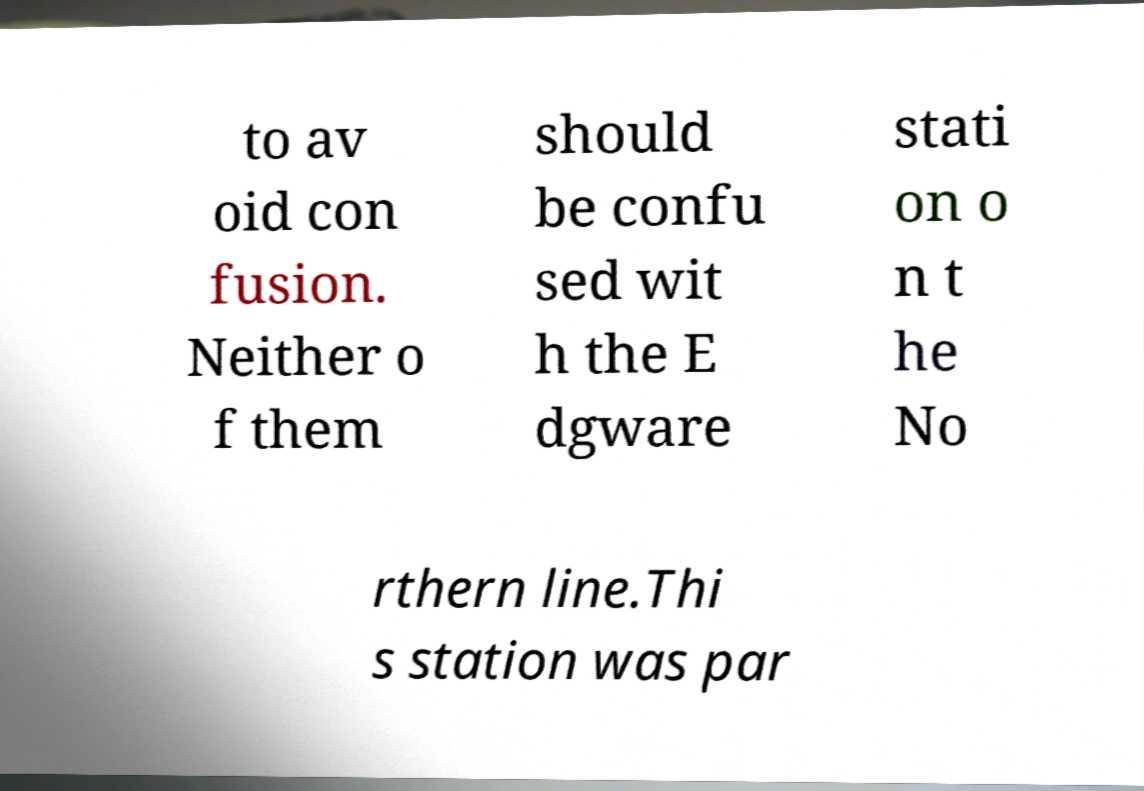Please identify and transcribe the text found in this image. to av oid con fusion. Neither o f them should be confu sed wit h the E dgware stati on o n t he No rthern line.Thi s station was par 